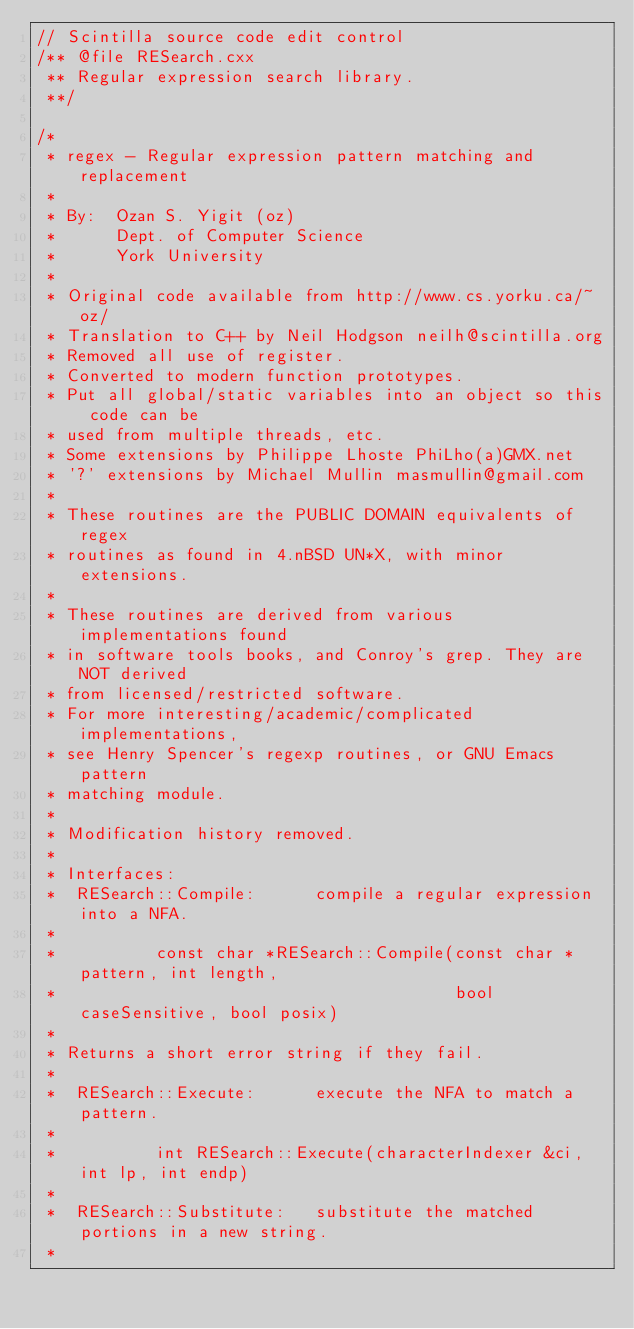Convert code to text. <code><loc_0><loc_0><loc_500><loc_500><_C++_>// Scintilla source code edit control
/** @file RESearch.cxx
 ** Regular expression search library.
 **/

/*
 * regex - Regular expression pattern matching and replacement
 *
 * By:  Ozan S. Yigit (oz)
 *      Dept. of Computer Science
 *      York University
 *
 * Original code available from http://www.cs.yorku.ca/~oz/
 * Translation to C++ by Neil Hodgson neilh@scintilla.org
 * Removed all use of register.
 * Converted to modern function prototypes.
 * Put all global/static variables into an object so this code can be
 * used from multiple threads, etc.
 * Some extensions by Philippe Lhoste PhiLho(a)GMX.net
 * '?' extensions by Michael Mullin masmullin@gmail.com
 *
 * These routines are the PUBLIC DOMAIN equivalents of regex
 * routines as found in 4.nBSD UN*X, with minor extensions.
 *
 * These routines are derived from various implementations found
 * in software tools books, and Conroy's grep. They are NOT derived
 * from licensed/restricted software.
 * For more interesting/academic/complicated implementations,
 * see Henry Spencer's regexp routines, or GNU Emacs pattern
 * matching module.
 *
 * Modification history removed.
 *
 * Interfaces:
 *  RESearch::Compile:      compile a regular expression into a NFA.
 *
 *          const char *RESearch::Compile(const char *pattern, int length,
 *                                        bool caseSensitive, bool posix)
 *
 * Returns a short error string if they fail.
 *
 *  RESearch::Execute:      execute the NFA to match a pattern.
 *
 *          int RESearch::Execute(characterIndexer &ci, int lp, int endp)
 *
 *  RESearch::Substitute:   substitute the matched portions in a new string.
 *</code> 